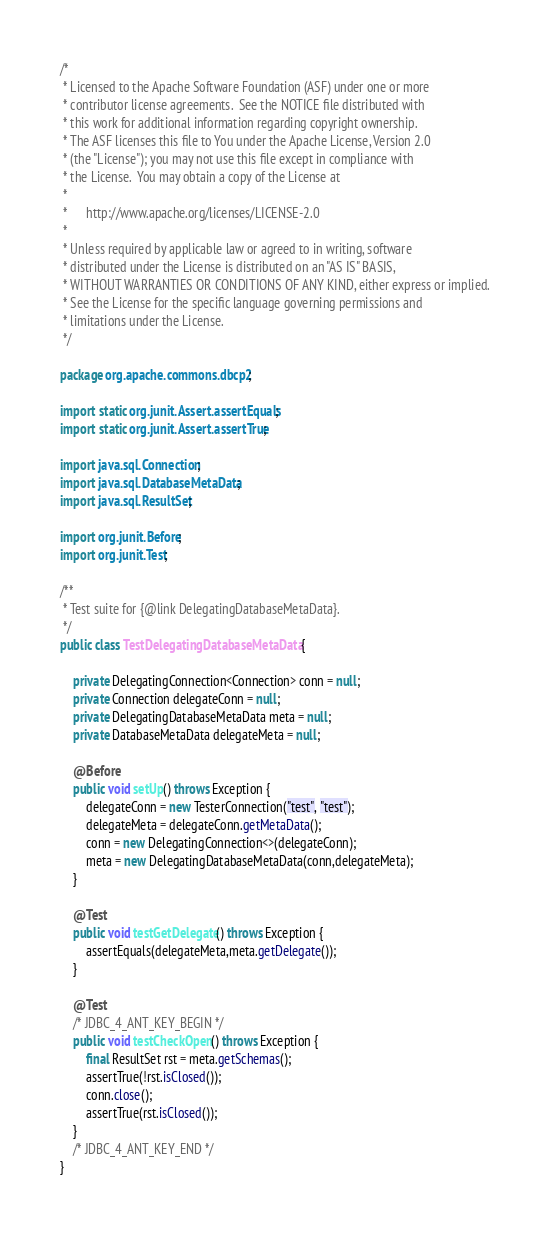<code> <loc_0><loc_0><loc_500><loc_500><_Java_>/*
 * Licensed to the Apache Software Foundation (ASF) under one or more
 * contributor license agreements.  See the NOTICE file distributed with
 * this work for additional information regarding copyright ownership.
 * The ASF licenses this file to You under the Apache License, Version 2.0
 * (the "License"); you may not use this file except in compliance with
 * the License.  You may obtain a copy of the License at
 *
 *      http://www.apache.org/licenses/LICENSE-2.0
 *
 * Unless required by applicable law or agreed to in writing, software
 * distributed under the License is distributed on an "AS IS" BASIS,
 * WITHOUT WARRANTIES OR CONDITIONS OF ANY KIND, either express or implied.
 * See the License for the specific language governing permissions and
 * limitations under the License.
 */

package org.apache.commons.dbcp2;

import static org.junit.Assert.assertEquals;
import static org.junit.Assert.assertTrue;

import java.sql.Connection;
import java.sql.DatabaseMetaData;
import java.sql.ResultSet;

import org.junit.Before;
import org.junit.Test;

/**
 * Test suite for {@link DelegatingDatabaseMetaData}.
 */
public class TestDelegatingDatabaseMetaData {

    private DelegatingConnection<Connection> conn = null;
    private Connection delegateConn = null;
    private DelegatingDatabaseMetaData meta = null;
    private DatabaseMetaData delegateMeta = null;

    @Before
    public void setUp() throws Exception {
        delegateConn = new TesterConnection("test", "test");
        delegateMeta = delegateConn.getMetaData();
        conn = new DelegatingConnection<>(delegateConn);
        meta = new DelegatingDatabaseMetaData(conn,delegateMeta);
    }

    @Test
    public void testGetDelegate() throws Exception {
        assertEquals(delegateMeta,meta.getDelegate());
    }

    @Test
    /* JDBC_4_ANT_KEY_BEGIN */
    public void testCheckOpen() throws Exception {
        final ResultSet rst = meta.getSchemas();
        assertTrue(!rst.isClosed());
        conn.close();
        assertTrue(rst.isClosed());
    }
    /* JDBC_4_ANT_KEY_END */
}
</code> 